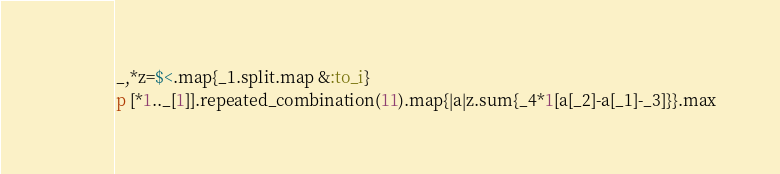Convert code to text. <code><loc_0><loc_0><loc_500><loc_500><_Ruby_>_,*z=$<.map{_1.split.map &:to_i}
p [*1.._[1]].repeated_combination(11).map{|a|z.sum{_4*1[a[_2]-a[_1]-_3]}}.max</code> 